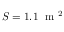<formula> <loc_0><loc_0><loc_500><loc_500>S = 1 . 1 m ^ { 2 }</formula> 